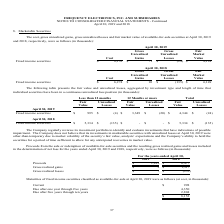From Frequency Electronics's financial document, What is the cost of the fixed income securities in 2019 and 2018 respectively? The document shows two values: $8,152 and $6,274 (in thousands). From the document: "Cost Gains Losses Value Fixed income securities $ 6,274 $ 10 $ (135) $ 6,149 Cost Gains Losses Value Fixed income securities $ 8,152 $ 71 $ (24) $ 8,1..." Also, What is the gross unrealized gains of the fixed income securities in 2019 and 2018 respectively? The document shows two values: $71 and $10 (in thousands). From the document: "ns Losses Value Fixed income securities $ 8,152 $ 71 $ (24) $ 8,199 ns Losses Value Fixed income securities $ 6,274 $ 10 $ (135) $ 6,149..." Also, What does the table show? The cost, gross unrealized gains, gross unrealized losses and fair market value of available-for-sale securities at April 30, 2019 and 2018, respectively. The document states: "April 30, 2019 and 2018 8. Marketable Securities The cost, gross unrealized gains, gross unrealized losses and fair market value of available-for-sale..." Also, can you calculate: What is the difference in cost of the fixed income securities between 2018 and 2019? Based on the calculation: 8,152-6,274, the result is 1878 (in thousands). This is based on the information: "Cost Gains Losses Value Fixed income securities $ 8,152 $ 71 $ (24) $ 8,199 Cost Gains Losses Value Fixed income securities $ 6,274 $ 10 $ (135) $ 6,149..." The key data points involved are: 6,274, 8,152. Also, can you calculate: What is the percentage change in the fair market value between 2018 and 2019? To answer this question, I need to perform calculations using the financial data. The calculation is: (8,199-6,149)/6,149, which equals 33.34 (percentage). This is based on the information: "lue Fixed income securities $ 8,152 $ 71 $ (24) $ 8,199 ue Fixed income securities $ 6,274 $ 10 $ (135) $ 6,149..." The key data points involved are: 6,149, 8,199. Also, can you calculate: What is the average fair market value for 2018 and 2019? To answer this question, I need to perform calculations using the financial data. The calculation is: (8,199+6,149)/2, which equals 7174 (in thousands). This is based on the information: "lue Fixed income securities $ 8,152 $ 71 $ (24) $ 8,199 ue Fixed income securities $ 6,274 $ 10 $ (135) $ 6,149..." The key data points involved are: 6,149, 8,199. 